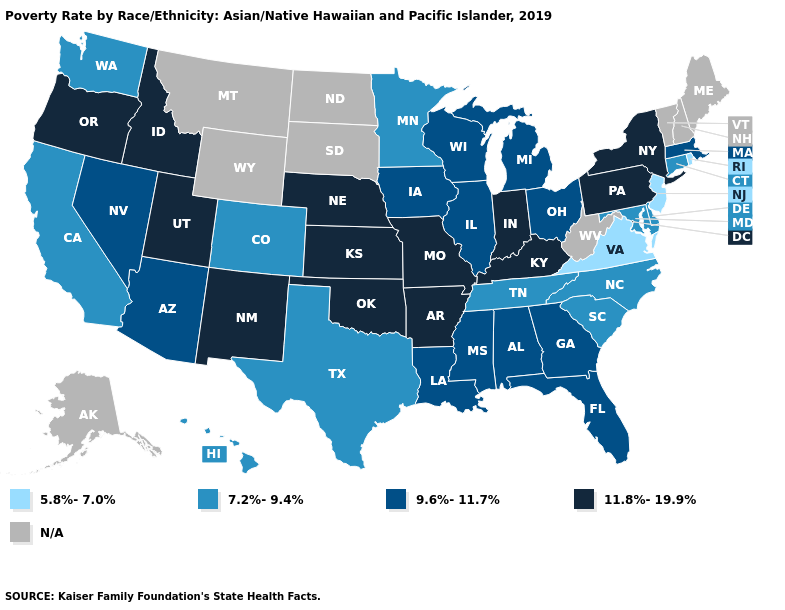Among the states that border Kansas , does Oklahoma have the lowest value?
Keep it brief. No. Name the states that have a value in the range 9.6%-11.7%?
Answer briefly. Alabama, Arizona, Florida, Georgia, Illinois, Iowa, Louisiana, Massachusetts, Michigan, Mississippi, Nevada, Ohio, Wisconsin. What is the highest value in states that border Texas?
Concise answer only. 11.8%-19.9%. What is the value of Wisconsin?
Write a very short answer. 9.6%-11.7%. What is the value of Vermont?
Write a very short answer. N/A. Does the first symbol in the legend represent the smallest category?
Concise answer only. Yes. Does Iowa have the highest value in the MidWest?
Write a very short answer. No. Name the states that have a value in the range 11.8%-19.9%?
Keep it brief. Arkansas, Idaho, Indiana, Kansas, Kentucky, Missouri, Nebraska, New Mexico, New York, Oklahoma, Oregon, Pennsylvania, Utah. Among the states that border Nebraska , does Colorado have the lowest value?
Keep it brief. Yes. Name the states that have a value in the range 5.8%-7.0%?
Concise answer only. New Jersey, Rhode Island, Virginia. Which states have the highest value in the USA?
Write a very short answer. Arkansas, Idaho, Indiana, Kansas, Kentucky, Missouri, Nebraska, New Mexico, New York, Oklahoma, Oregon, Pennsylvania, Utah. What is the value of Idaho?
Short answer required. 11.8%-19.9%. Does Massachusetts have the highest value in the Northeast?
Short answer required. No. What is the value of Illinois?
Be succinct. 9.6%-11.7%. What is the lowest value in states that border New Mexico?
Answer briefly. 7.2%-9.4%. 